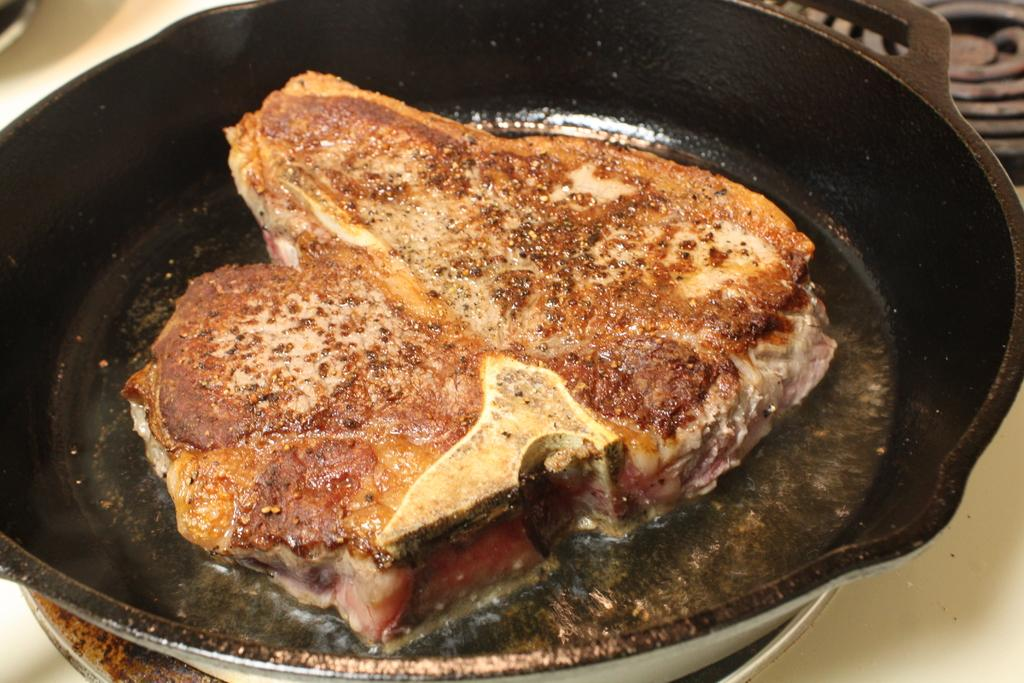What is on the pan that is visible in the image? There is a food item on a pan in the image. Where is the pan located in the image? The pan is on a stove in the image. How many oranges are visible on the stove in the image? There are no oranges visible in the image; it features a food item on a pan on a stove. What type of dinosaur can be seen roaming around the stove in the image? There are no dinosaurs present in the image. 